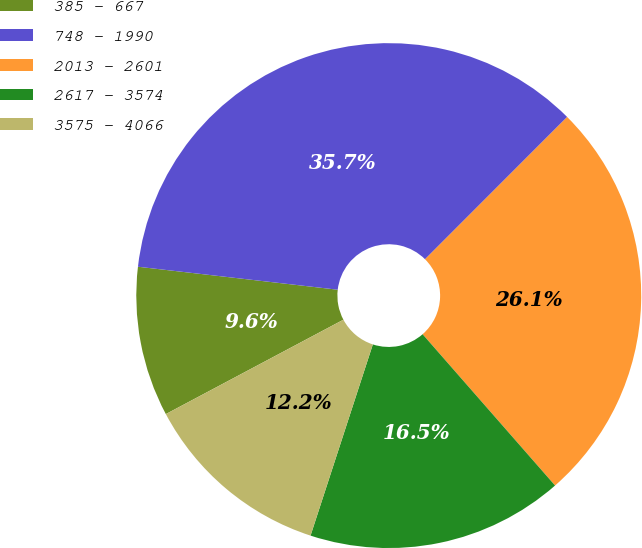Convert chart. <chart><loc_0><loc_0><loc_500><loc_500><pie_chart><fcel>385 - 667<fcel>748 - 1990<fcel>2013 - 2601<fcel>2617 - 3574<fcel>3575 - 4066<nl><fcel>9.6%<fcel>35.67%<fcel>26.06%<fcel>16.46%<fcel>12.21%<nl></chart> 